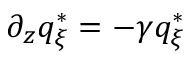<formula> <loc_0><loc_0><loc_500><loc_500>\partial _ { z } q _ { \xi } ^ { * } = - \gamma q _ { \xi } ^ { * }</formula> 